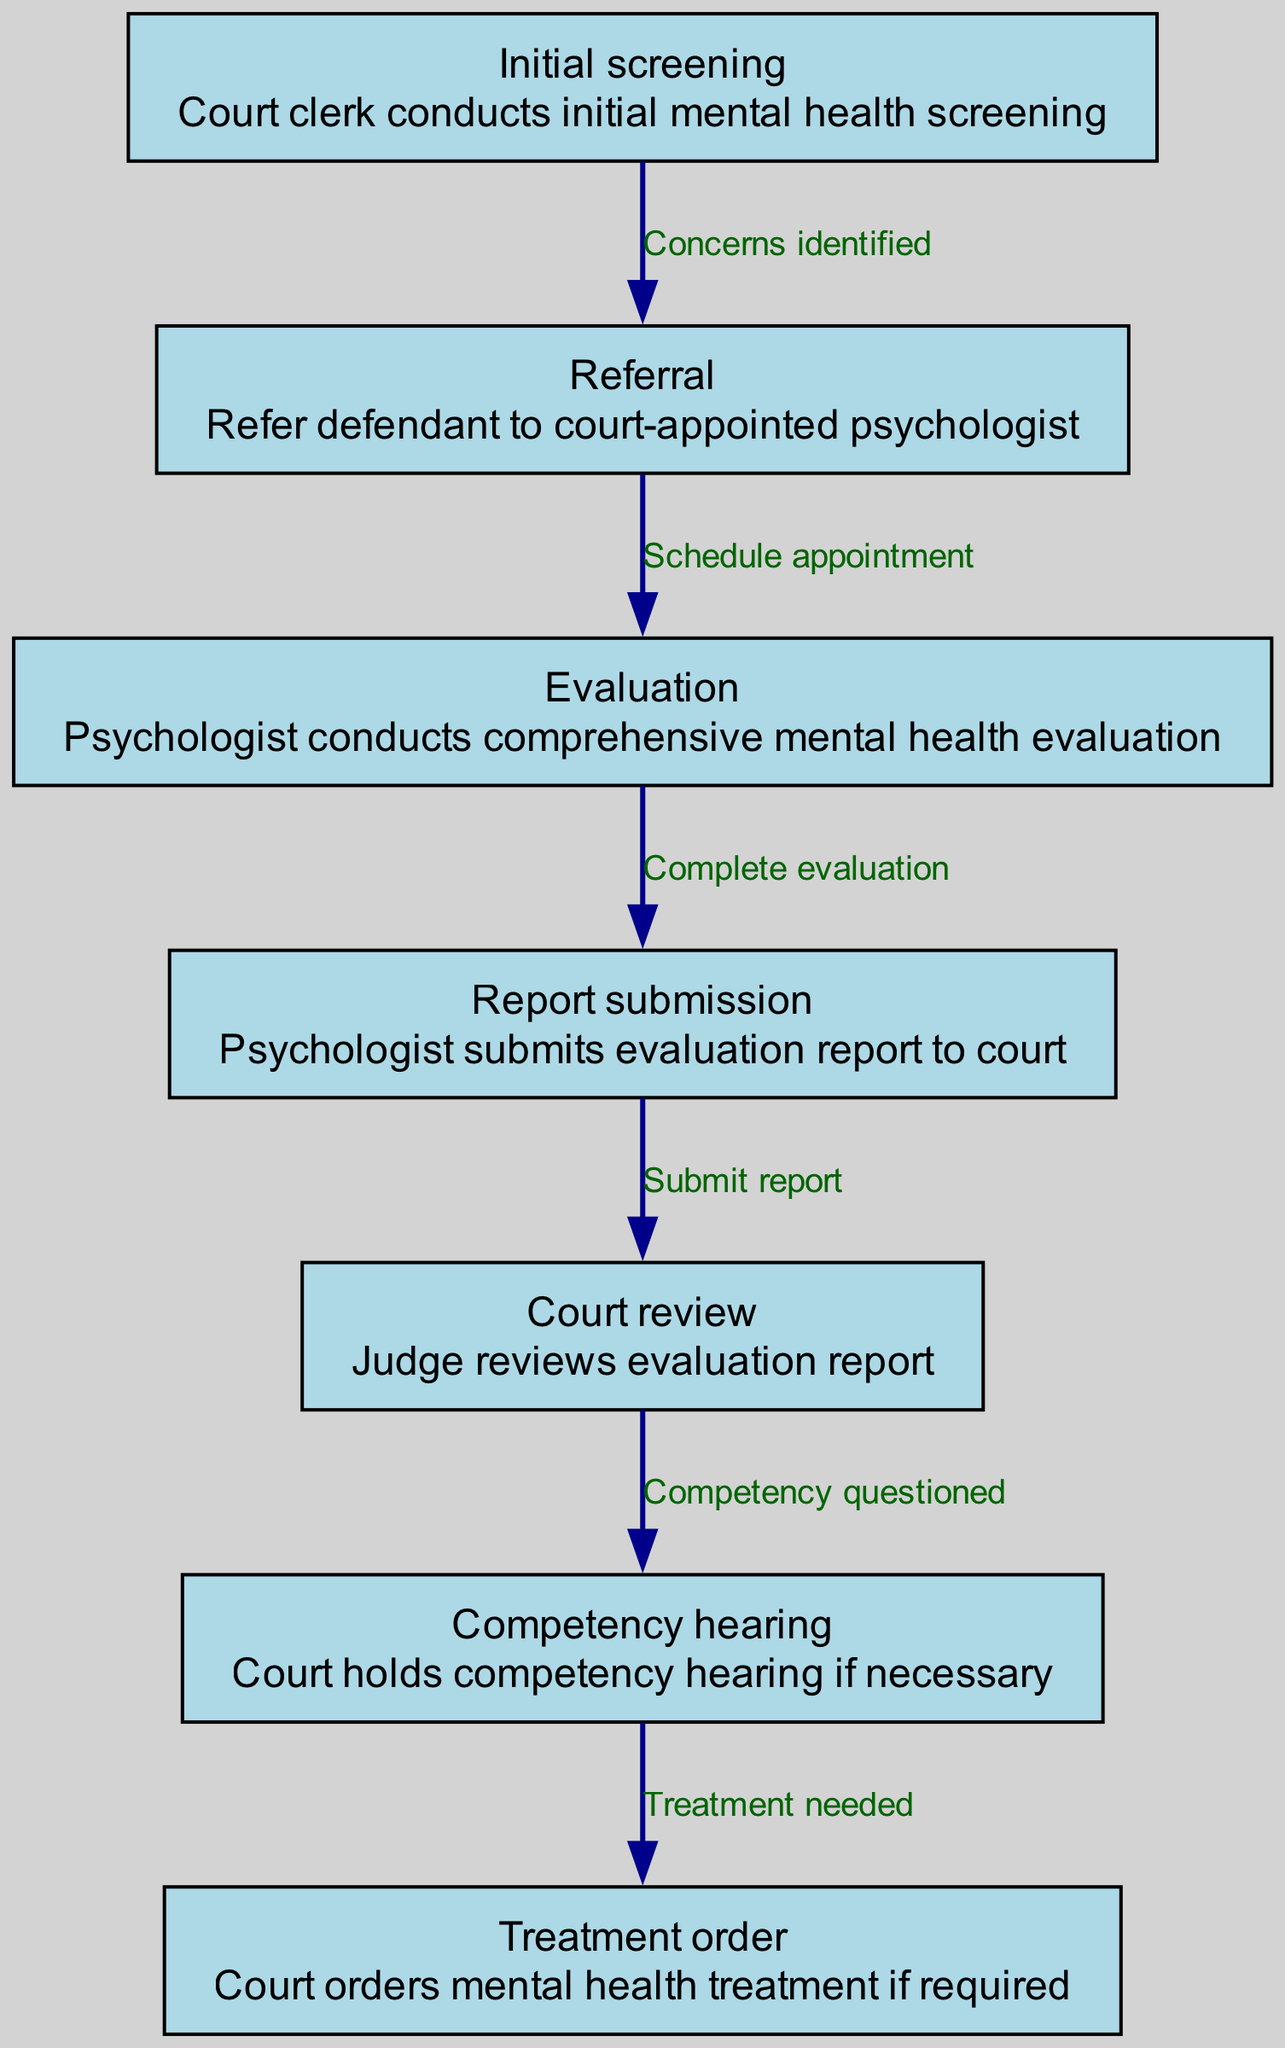What is the first step in the pathway? The first step in the pathway is "Initial screening," where the court clerk conducts initial mental health screening.
Answer: Initial screening How many nodes are in the diagram? The diagram contains 7 nodes, each representing a distinct step in the clinical pathway for mental health evaluations.
Answer: 7 What happens after the psychologist conducts the evaluation? After the psychologist conducts the evaluation, they submit the evaluation report to the court, indicated by the "Report submission" node.
Answer: Report submission Which node follows the "Court review" node? The "Competency hearing" node follows the "Court review" node, but only if the competency is questioned based on the evaluation report.
Answer: Competency hearing What is the relationship between "Referral" and "Evaluation"? The relationship between "Referral" and "Evaluation" is that the referral leads to scheduling an appointment for the evaluation.
Answer: Schedule appointment If the competency is questioned, what is the next step? If the competency is questioned, the next step is to hold a "Competency hearing" where the court assesses the defendant's mental state.
Answer: Competency hearing What does the court do if treatment is needed? If treatment is needed, the court issues a "Treatment order" for the necessary mental health treatment as determined by the evaluation process.
Answer: Treatment order 